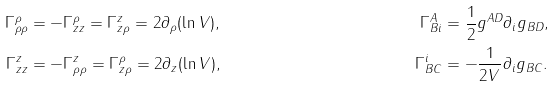<formula> <loc_0><loc_0><loc_500><loc_500>\Gamma ^ { \rho } _ { \rho \rho } & = - \Gamma ^ { \rho } _ { z z } = \Gamma ^ { z } _ { z \rho } = 2 \partial _ { \rho } ( \ln V ) , & \Gamma ^ { A } _ { B i } & = \frac { 1 } { 2 } g ^ { A D } \partial _ { i } g _ { B D } , \\ \Gamma ^ { z } _ { z z } & = - \Gamma ^ { z } _ { \rho \rho } = \Gamma ^ { \rho } _ { z \rho } = 2 \partial _ { z } ( \ln V ) , & \Gamma ^ { i } _ { B C } & = - \frac { 1 } { 2 V } \partial _ { i } g _ { B C } .</formula> 